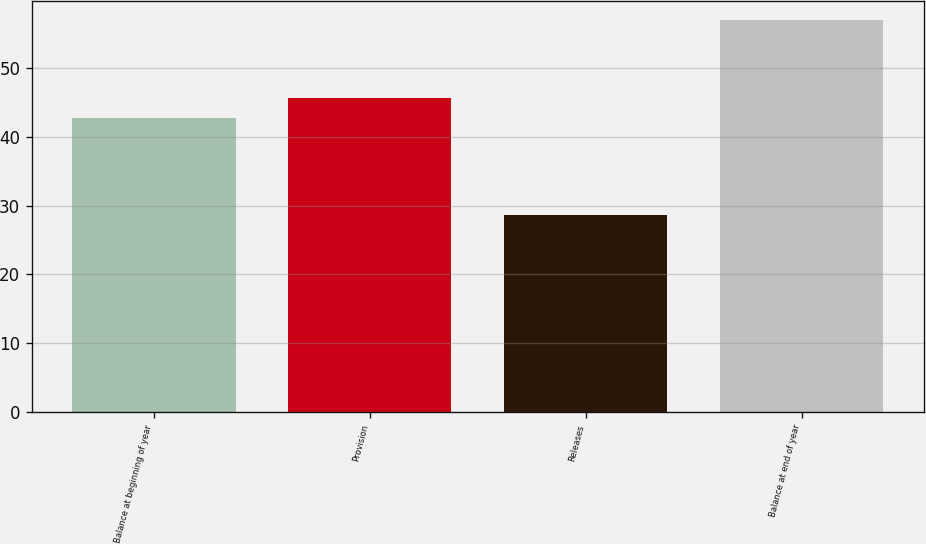Convert chart to OTSL. <chart><loc_0><loc_0><loc_500><loc_500><bar_chart><fcel>Balance at beginning of year<fcel>Provision<fcel>Releases<fcel>Balance at end of year<nl><fcel>42.8<fcel>45.63<fcel>28.7<fcel>57<nl></chart> 